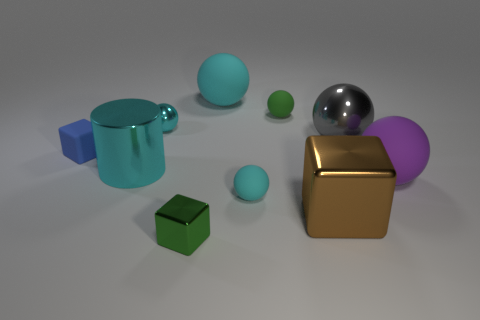Subtract all cyan cylinders. How many cyan spheres are left? 3 Subtract 2 spheres. How many spheres are left? 4 Subtract all purple spheres. How many spheres are left? 5 Subtract all tiny cyan rubber spheres. How many spheres are left? 5 Subtract all gray balls. Subtract all purple cubes. How many balls are left? 5 Subtract all spheres. How many objects are left? 4 Add 4 big cylinders. How many big cylinders exist? 5 Subtract 0 yellow blocks. How many objects are left? 10 Subtract all gray shiny spheres. Subtract all tiny green metallic blocks. How many objects are left? 8 Add 4 green blocks. How many green blocks are left? 5 